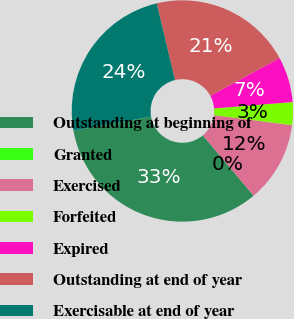<chart> <loc_0><loc_0><loc_500><loc_500><pie_chart><fcel>Outstanding at beginning of<fcel>Granted<fcel>Exercised<fcel>Forfeited<fcel>Expired<fcel>Outstanding at end of year<fcel>Exercisable at end of year<nl><fcel>33.3%<fcel>0.0%<fcel>11.82%<fcel>3.33%<fcel>6.66%<fcel>20.78%<fcel>24.11%<nl></chart> 